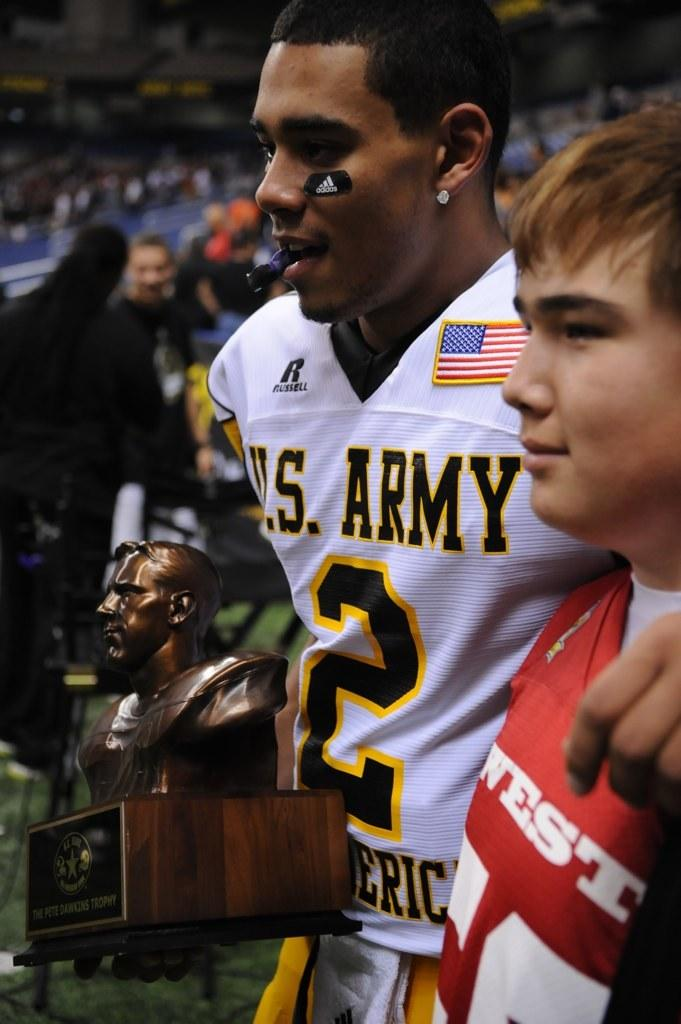<image>
Create a compact narrative representing the image presented. the player is wearing US Army number 2 jersey 